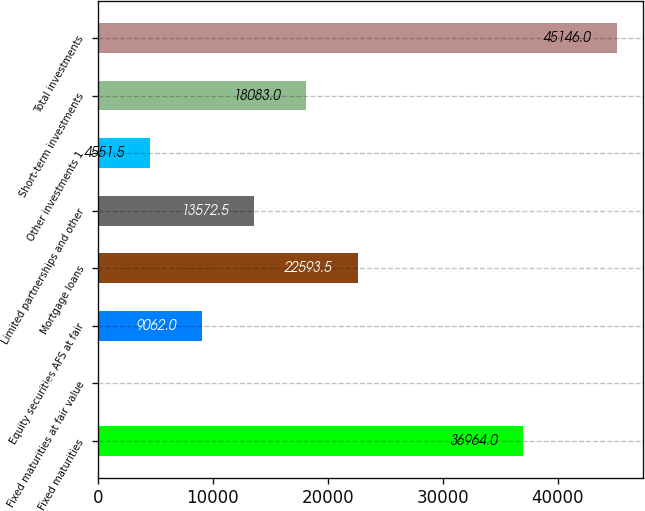Convert chart to OTSL. <chart><loc_0><loc_0><loc_500><loc_500><bar_chart><fcel>Fixed maturities<fcel>Fixed maturities at fair value<fcel>Equity securities AFS at fair<fcel>Mortgage loans<fcel>Limited partnerships and other<fcel>Other investments 1<fcel>Short-term investments<fcel>Total investments<nl><fcel>36964<fcel>41<fcel>9062<fcel>22593.5<fcel>13572.5<fcel>4551.5<fcel>18083<fcel>45146<nl></chart> 